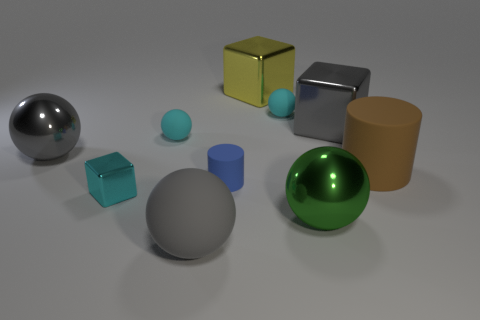Subtract all purple cubes. How many gray spheres are left? 2 Subtract all gray balls. How many balls are left? 3 Subtract all big gray shiny spheres. How many spheres are left? 4 Subtract 3 balls. How many balls are left? 2 Subtract all blocks. How many objects are left? 7 Subtract all purple spheres. Subtract all green cubes. How many spheres are left? 5 Subtract all gray metallic objects. Subtract all small cyan things. How many objects are left? 5 Add 7 tiny cylinders. How many tiny cylinders are left? 8 Add 5 spheres. How many spheres exist? 10 Subtract 0 green cylinders. How many objects are left? 10 